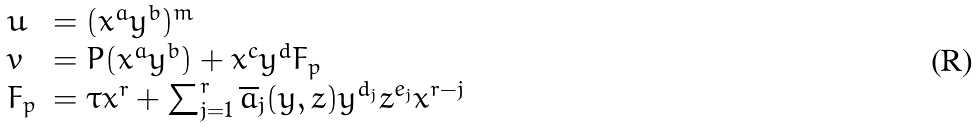<formula> <loc_0><loc_0><loc_500><loc_500>\begin{array} { l l } u & = ( x ^ { a } y ^ { b } ) ^ { m } \\ v & = P ( x ^ { a } y ^ { b } ) + x ^ { c } y ^ { d } F _ { p } \\ F _ { p } & = \tau x ^ { r } + \sum _ { j = 1 } ^ { r } \overline { a } _ { j } ( y , z ) y ^ { d _ { j } } z ^ { e _ { j } } x ^ { r - j } \end{array}</formula> 